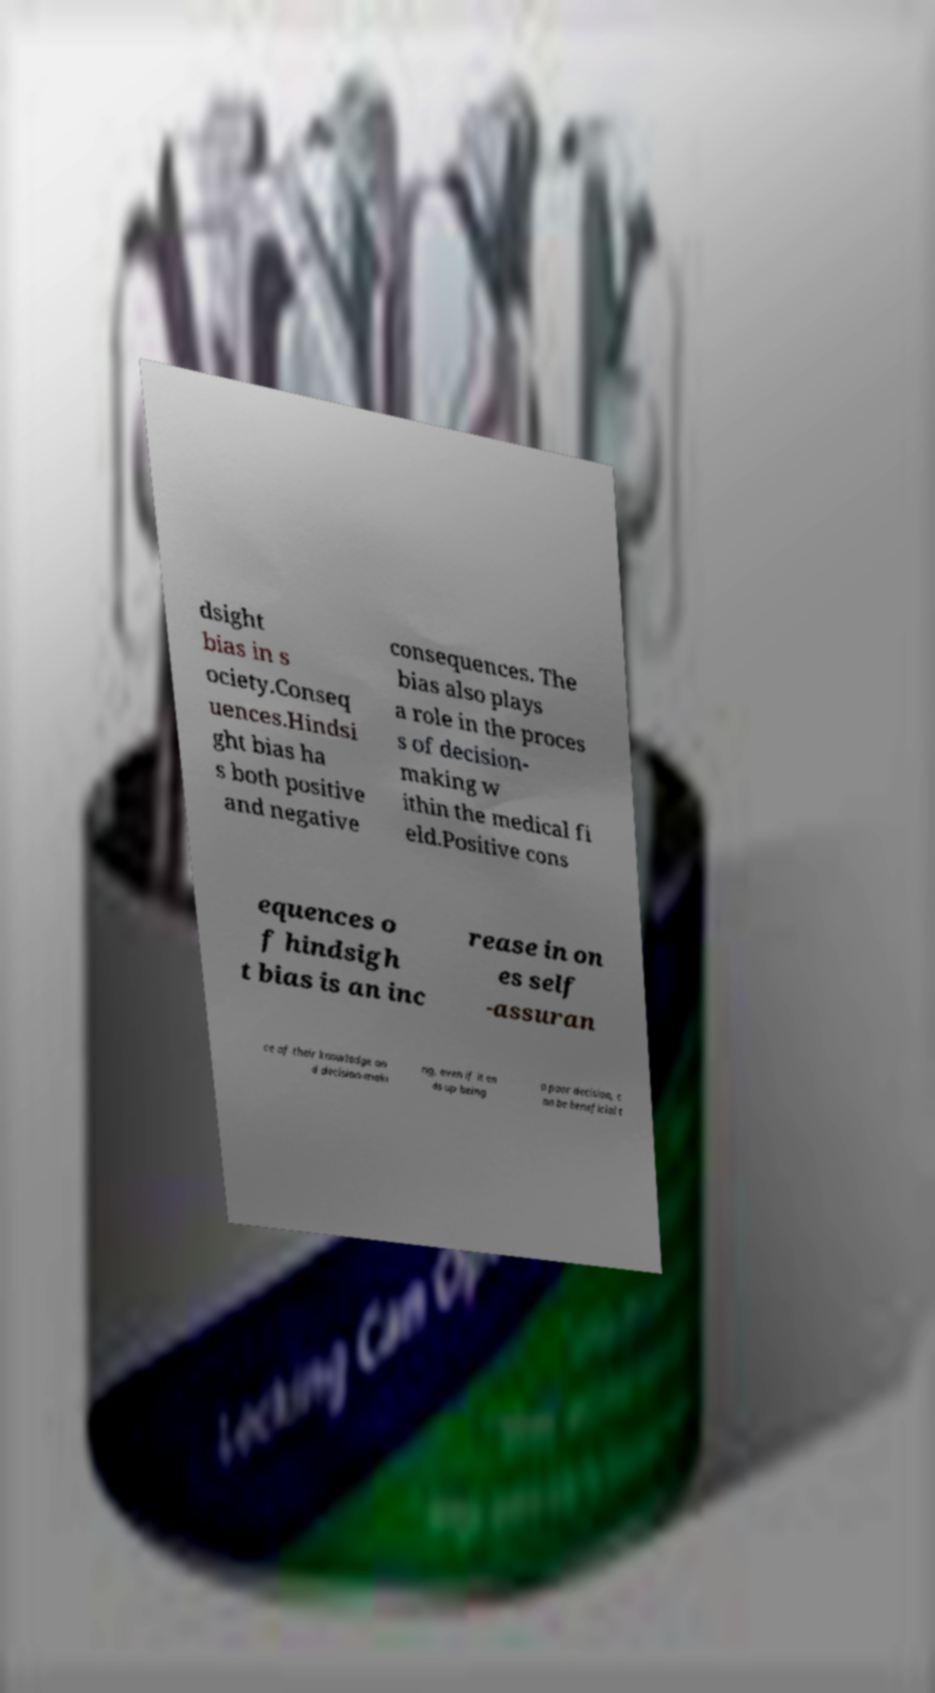For documentation purposes, I need the text within this image transcribed. Could you provide that? dsight bias in s ociety.Conseq uences.Hindsi ght bias ha s both positive and negative consequences. The bias also plays a role in the proces s of decision- making w ithin the medical fi eld.Positive cons equences o f hindsigh t bias is an inc rease in on es self -assuran ce of their knowledge an d decision-maki ng, even if it en ds up being a poor decision, c an be beneficial t 